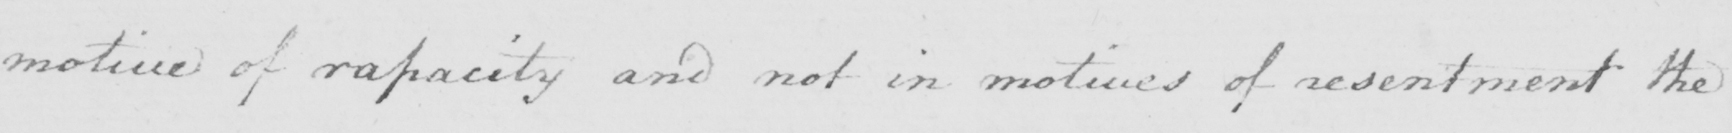Can you tell me what this handwritten text says? motive of rapacity and not in motives of resentment the 